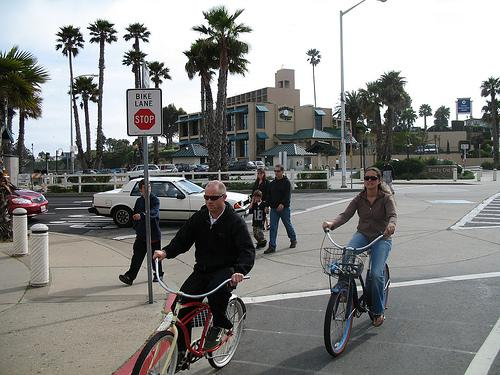Question: where are the people?
Choices:
A. At a bar.
B. Bikes.
C. At a concert.
D. In the living room.
Answer with the letter. Answer: B Question: why are the people on bikes?
Choices:
A. Racing.
B. Exercising.
C. Only transportation.
D. To ride.
Answer with the letter. Answer: D 